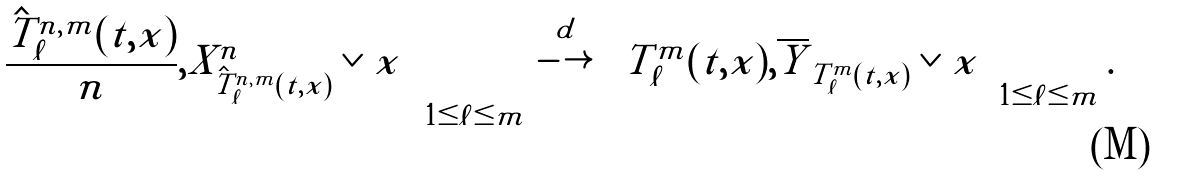<formula> <loc_0><loc_0><loc_500><loc_500>\left ( \frac { \hat { T } ^ { n , m } _ { \ell } ( t , x ) } { n } , X ^ { n } _ { \hat { T } ^ { n , m } _ { \ell } ( t , x ) } \vee x \right ) _ { 1 \leq \ell \leq m } \stackrel { d } { \longrightarrow } \left ( T ^ { m } _ { \ell } ( t , x ) , \overline { Y } _ { T ^ { m } _ { \ell } ( t , x ) } \vee x \right ) _ { 1 \leq \ell \leq m } .</formula> 